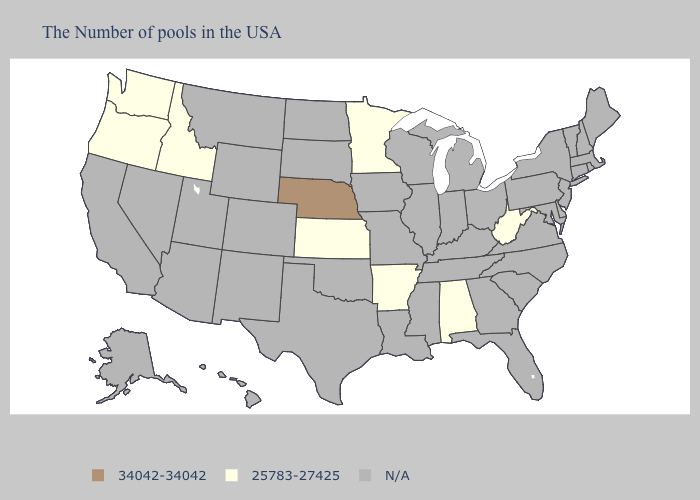Does Nebraska have the lowest value in the USA?
Answer briefly. No. Among the states that border Tennessee , which have the highest value?
Be succinct. Alabama, Arkansas. What is the highest value in the USA?
Quick response, please. 34042-34042. Is the legend a continuous bar?
Keep it brief. No. What is the value of Delaware?
Answer briefly. N/A. What is the value of Texas?
Keep it brief. N/A. What is the value of Arizona?
Short answer required. N/A. Is the legend a continuous bar?
Keep it brief. No. Does the first symbol in the legend represent the smallest category?
Keep it brief. No. Name the states that have a value in the range 34042-34042?
Be succinct. Nebraska. Name the states that have a value in the range 25783-27425?
Quick response, please. West Virginia, Alabama, Arkansas, Minnesota, Kansas, Idaho, Washington, Oregon. Name the states that have a value in the range 34042-34042?
Be succinct. Nebraska. Name the states that have a value in the range N/A?
Short answer required. Maine, Massachusetts, Rhode Island, New Hampshire, Vermont, Connecticut, New York, New Jersey, Delaware, Maryland, Pennsylvania, Virginia, North Carolina, South Carolina, Ohio, Florida, Georgia, Michigan, Kentucky, Indiana, Tennessee, Wisconsin, Illinois, Mississippi, Louisiana, Missouri, Iowa, Oklahoma, Texas, South Dakota, North Dakota, Wyoming, Colorado, New Mexico, Utah, Montana, Arizona, Nevada, California, Alaska, Hawaii. 